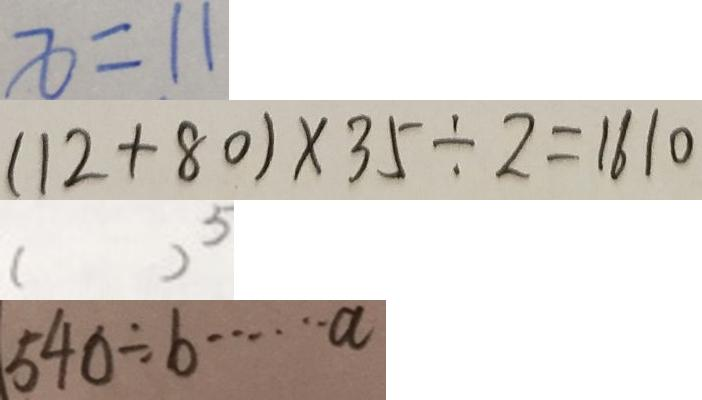<formula> <loc_0><loc_0><loc_500><loc_500>x = 1 1 
 ( 1 2 + 8 0 ) \times 3 5 \div 2 = 1 6 1 0 
 ( ) ^ { 5 } 
 5 4 0 \div b \cdots a</formula> 